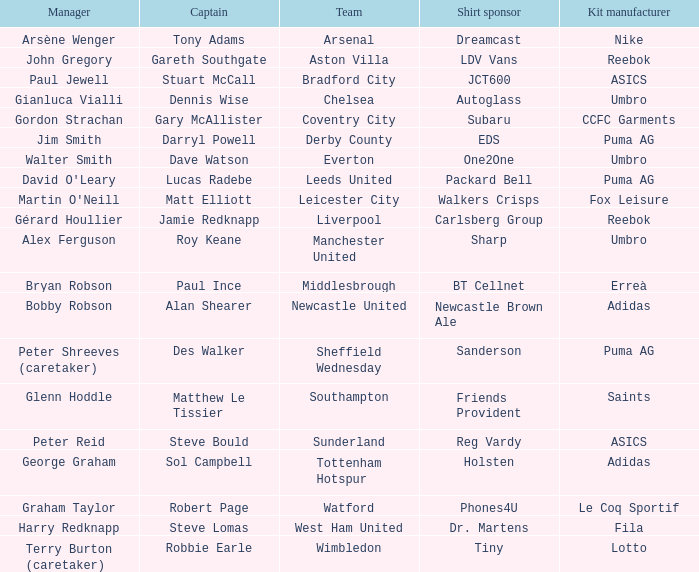Which Kit Manufacturer supports team Everton? Umbro. 